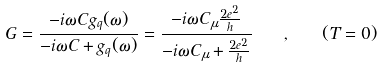Convert formula to latex. <formula><loc_0><loc_0><loc_500><loc_500>G = \frac { - i \omega C g _ { q } ( \omega ) } { - i \omega C + g _ { q } ( \omega ) } = \frac { - i \omega C _ { \mu } \frac { 2 e ^ { 2 } } { h } } { - i \omega C _ { \mu } + \frac { 2 e ^ { 2 } } { h } } \quad , \quad ( T = 0 )</formula> 